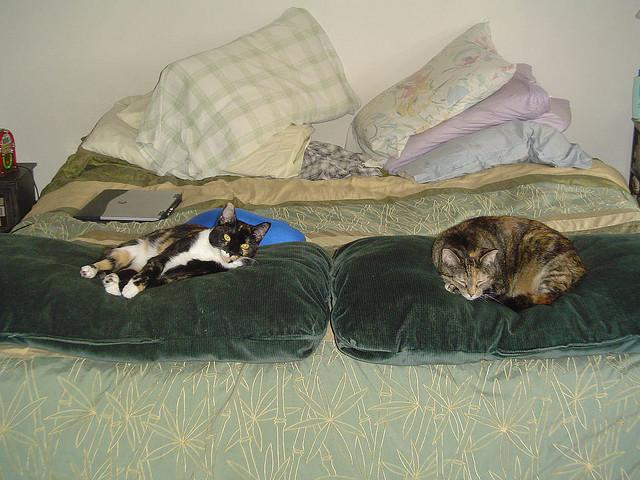How many cats are on pillows? Please explain your reasoning. two. There is a calico cat on one pillow and a tabby cat on the other pillow. 